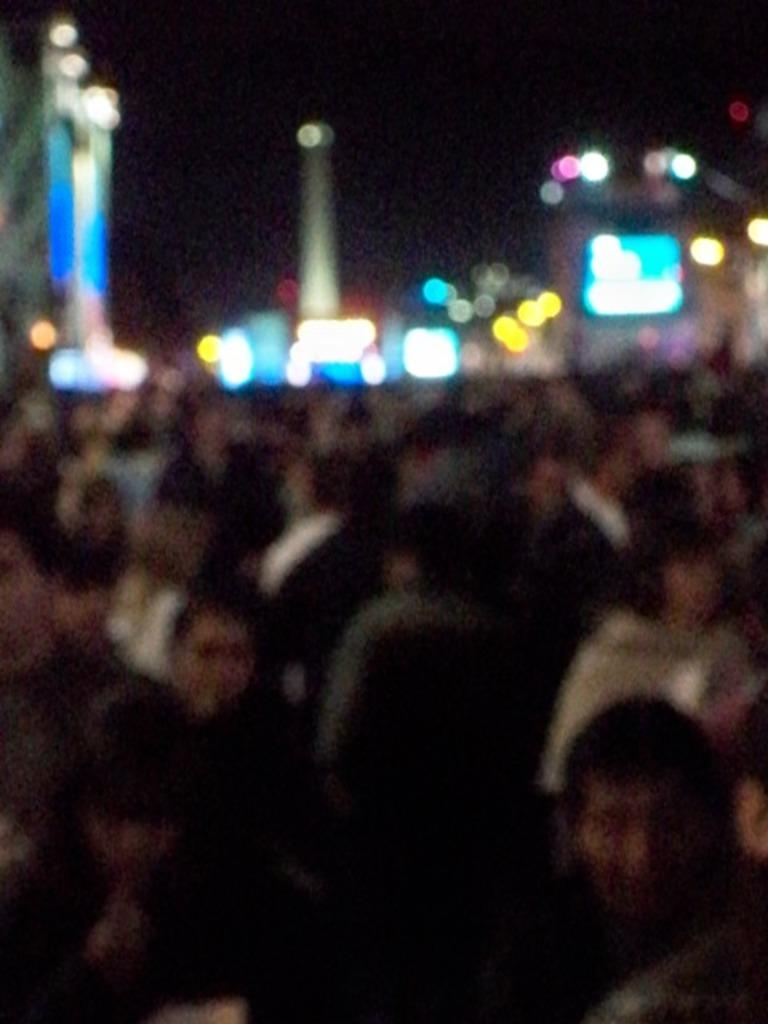What is the overall quality of the image? The image is blurry. Can you identify any specific subjects in the image? There is a group of people in the image, although their appearance may be unclear due to the blur. What else can be seen in the image? There are lights in the image, although their appearance may be unclear due to the blur. How would you describe the background of the image? The background of the image appears dark, although its appearance may be unclear due to the blur. What type of bag is being used to force the structure in the image? There is no bag, force, or structure present in the image; it is a blurry image of a group of people and lights against a dark background. 